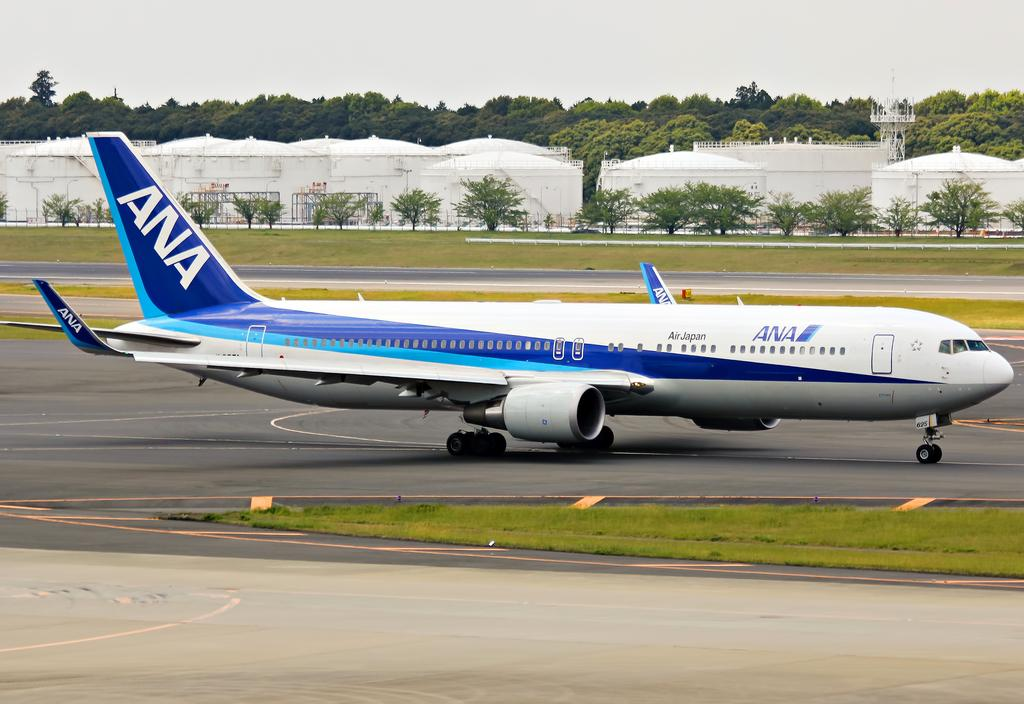What is the main subject of the image? The main subject of the image is an aeroplane. What can be seen in the background of the image? There are trees and white color buildings in the background of the image. What is visible in the sky in the image? The sky is visible in the background of the image. What is located at the bottom of the image? There is a road at the bottom of the image. What type of arithmetic problem is being solved by the plants in the image? There are no plants or arithmetic problems present in the image. 